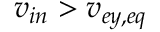<formula> <loc_0><loc_0><loc_500><loc_500>v _ { i n } > v _ { e y , e q }</formula> 